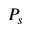<formula> <loc_0><loc_0><loc_500><loc_500>P _ { s }</formula> 